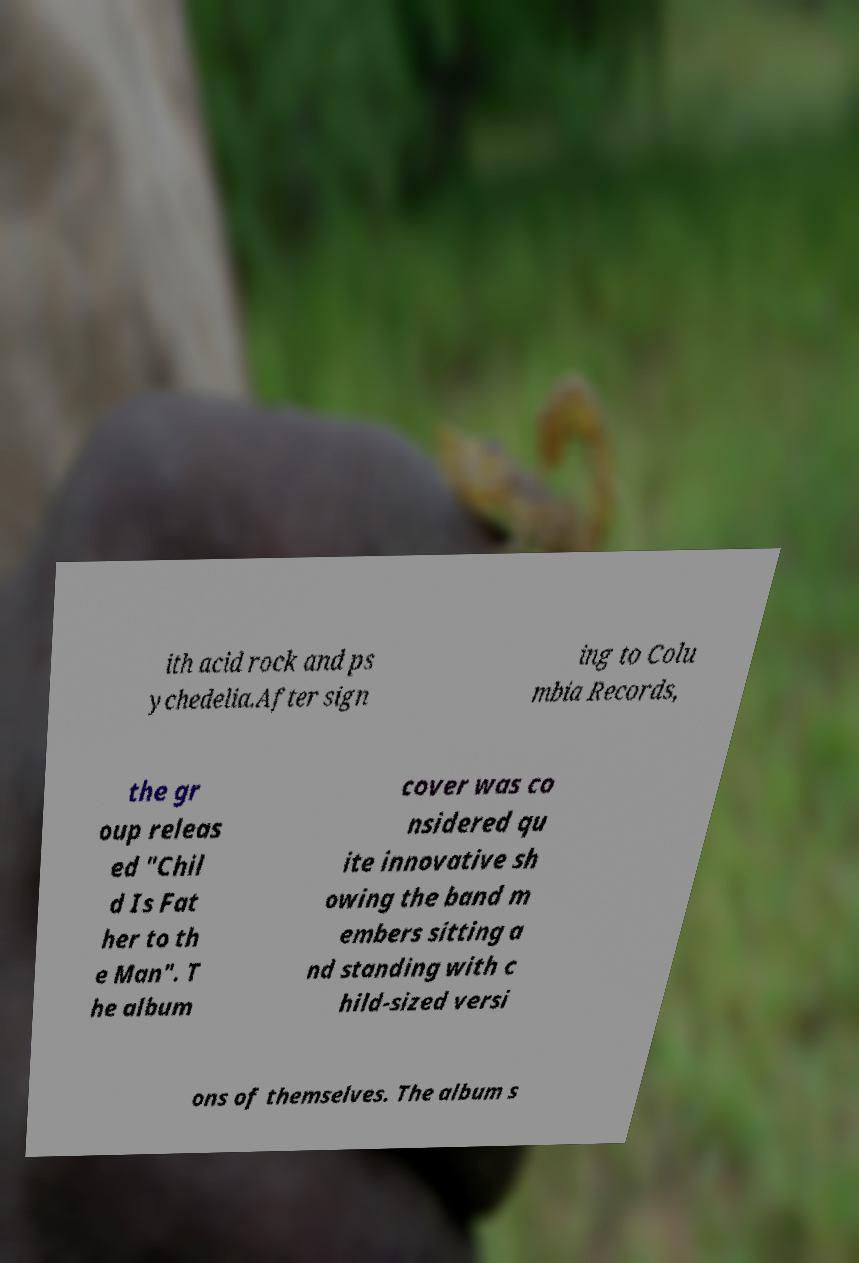Can you read and provide the text displayed in the image?This photo seems to have some interesting text. Can you extract and type it out for me? ith acid rock and ps ychedelia.After sign ing to Colu mbia Records, the gr oup releas ed "Chil d Is Fat her to th e Man". T he album cover was co nsidered qu ite innovative sh owing the band m embers sitting a nd standing with c hild-sized versi ons of themselves. The album s 